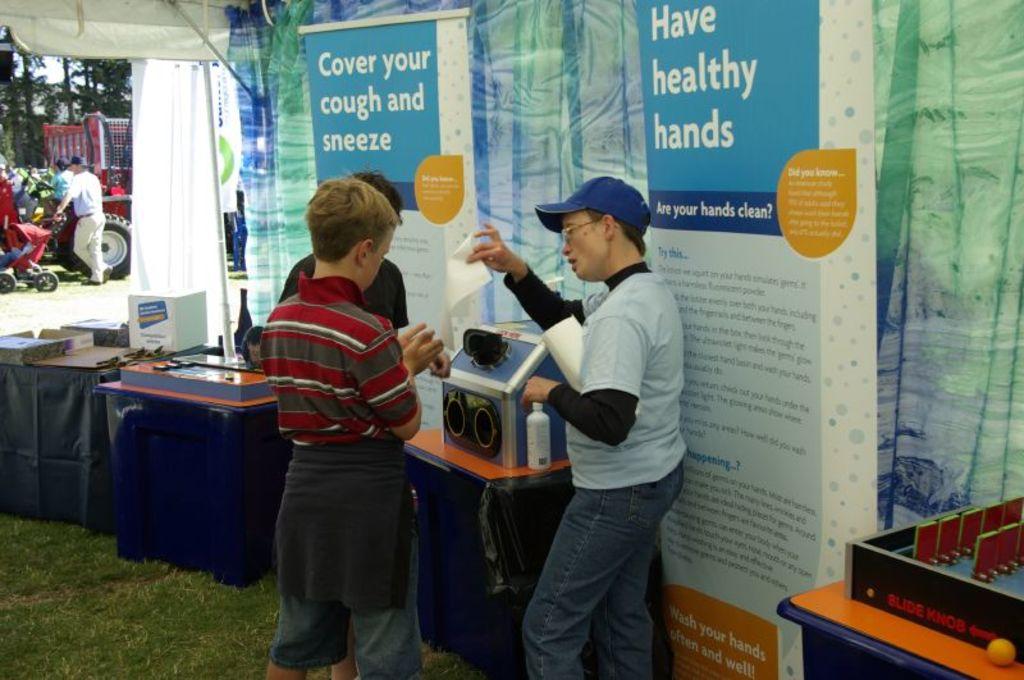What should you cover?
Your answer should be compact. Cough and sneeze. What does the sign say should be healthy?
Give a very brief answer. Hands. 